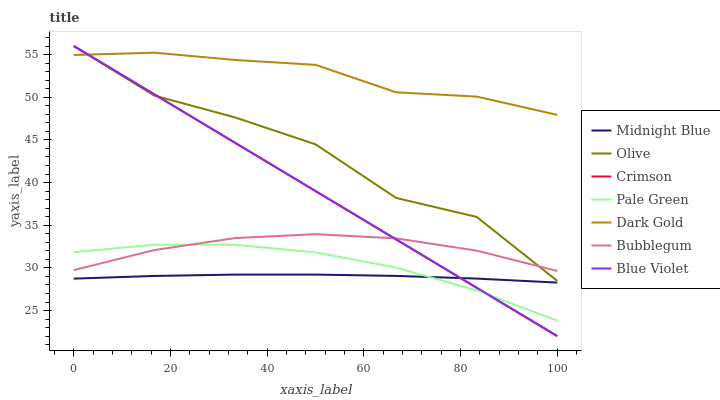Does Midnight Blue have the minimum area under the curve?
Answer yes or no. Yes. Does Dark Gold have the maximum area under the curve?
Answer yes or no. Yes. Does Bubblegum have the minimum area under the curve?
Answer yes or no. No. Does Bubblegum have the maximum area under the curve?
Answer yes or no. No. Is Blue Violet the smoothest?
Answer yes or no. Yes. Is Olive the roughest?
Answer yes or no. Yes. Is Dark Gold the smoothest?
Answer yes or no. No. Is Dark Gold the roughest?
Answer yes or no. No. Does Crimson have the lowest value?
Answer yes or no. Yes. Does Bubblegum have the lowest value?
Answer yes or no. No. Does Blue Violet have the highest value?
Answer yes or no. Yes. Does Dark Gold have the highest value?
Answer yes or no. No. Is Midnight Blue less than Olive?
Answer yes or no. Yes. Is Dark Gold greater than Midnight Blue?
Answer yes or no. Yes. Does Olive intersect Dark Gold?
Answer yes or no. Yes. Is Olive less than Dark Gold?
Answer yes or no. No. Is Olive greater than Dark Gold?
Answer yes or no. No. Does Midnight Blue intersect Olive?
Answer yes or no. No. 